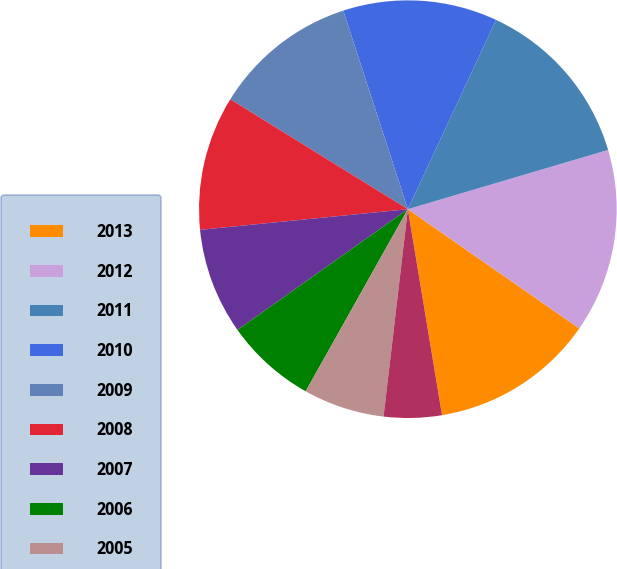<chart> <loc_0><loc_0><loc_500><loc_500><pie_chart><fcel>2013<fcel>2012<fcel>2011<fcel>2010<fcel>2009<fcel>2008<fcel>2007<fcel>2006<fcel>2005<fcel>2004<nl><fcel>12.71%<fcel>14.25%<fcel>13.48%<fcel>11.94%<fcel>11.17%<fcel>10.4%<fcel>8.23%<fcel>7.05%<fcel>6.28%<fcel>4.47%<nl></chart> 